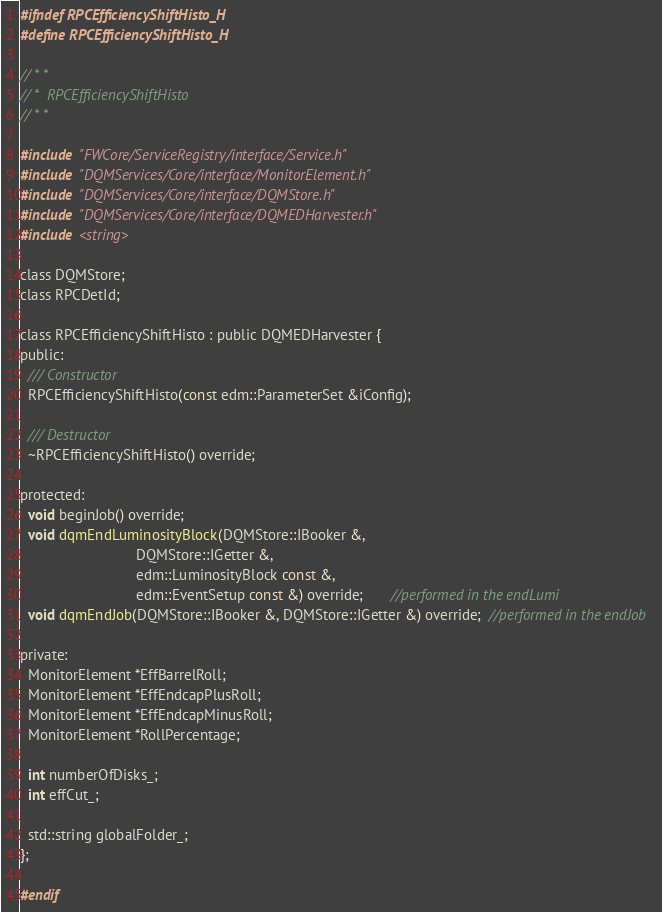Convert code to text. <code><loc_0><loc_0><loc_500><loc_500><_C_>#ifndef RPCEfficiencyShiftHisto_H
#define RPCEfficiencyShiftHisto_H

// * *
// *  RPCEfficiencyShiftHisto
// * *

#include "FWCore/ServiceRegistry/interface/Service.h"
#include "DQMServices/Core/interface/MonitorElement.h"
#include "DQMServices/Core/interface/DQMStore.h"
#include "DQMServices/Core/interface/DQMEDHarvester.h"
#include <string>

class DQMStore;
class RPCDetId;

class RPCEfficiencyShiftHisto : public DQMEDHarvester {
public:
  /// Constructor
  RPCEfficiencyShiftHisto(const edm::ParameterSet &iConfig);

  /// Destructor
  ~RPCEfficiencyShiftHisto() override;

protected:
  void beginJob() override;
  void dqmEndLuminosityBlock(DQMStore::IBooker &,
                             DQMStore::IGetter &,
                             edm::LuminosityBlock const &,
                             edm::EventSetup const &) override;       //performed in the endLumi
  void dqmEndJob(DQMStore::IBooker &, DQMStore::IGetter &) override;  //performed in the endJob

private:
  MonitorElement *EffBarrelRoll;
  MonitorElement *EffEndcapPlusRoll;
  MonitorElement *EffEndcapMinusRoll;
  MonitorElement *RollPercentage;

  int numberOfDisks_;
  int effCut_;

  std::string globalFolder_;
};

#endif
</code> 